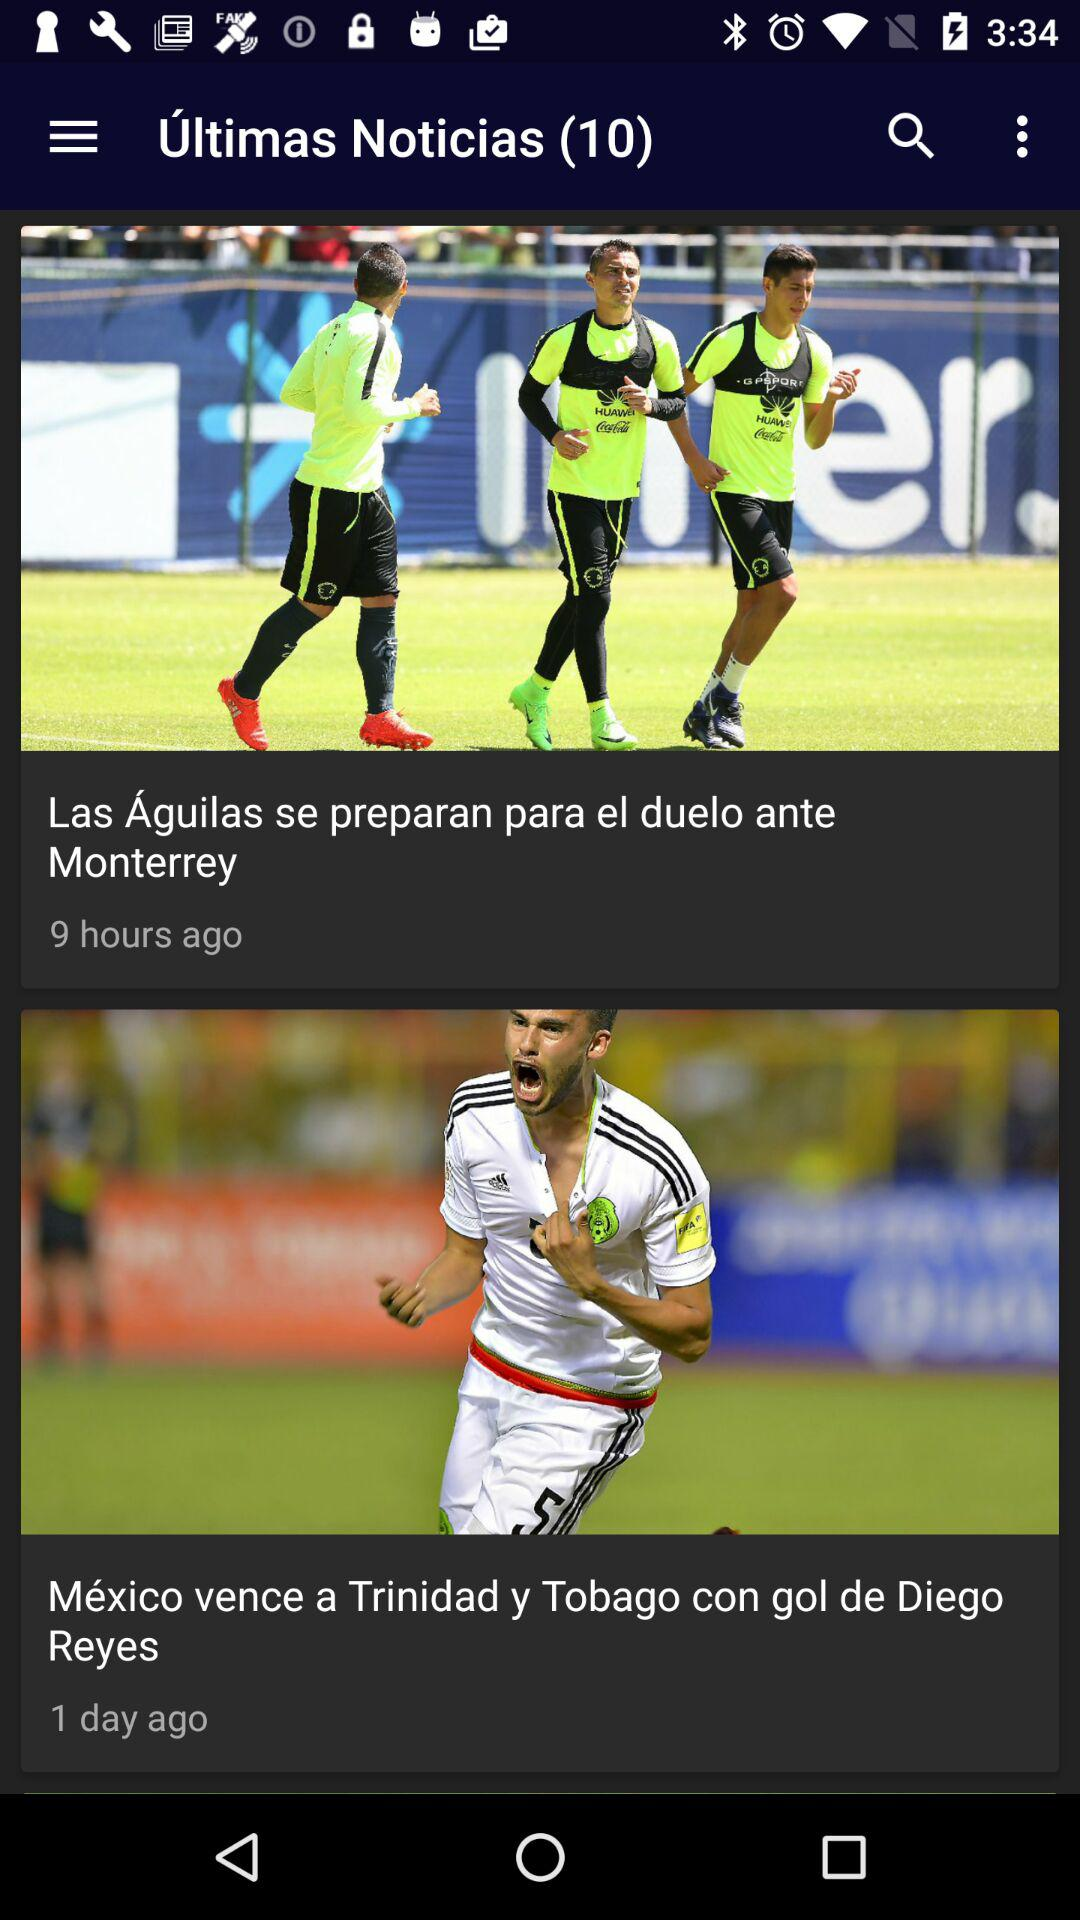How many more soccer players are in the first news item than the second?
Answer the question using a single word or phrase. 2 